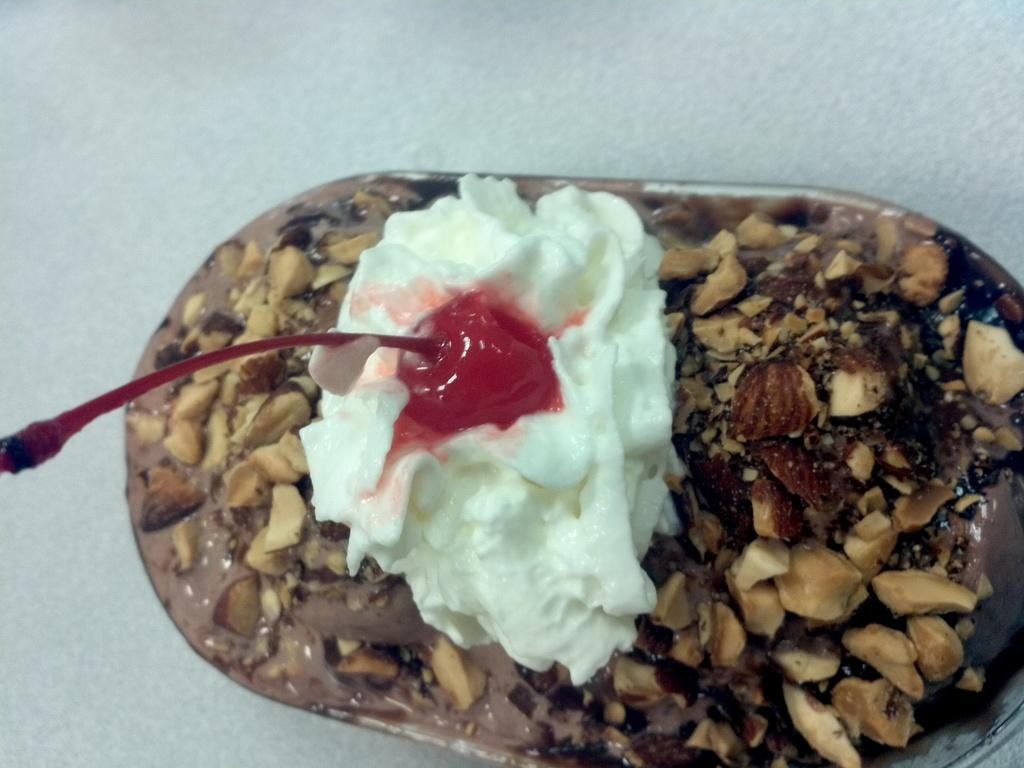What is the main subject of the image? There is a food item in the image. Can you describe the surface on which the food item is placed? The food item is on a white surface. How many basketballs are visible in the image? There are no basketballs present in the image. What type of tree can be seen growing on the white surface? There is no tree present in the image; it features a food item on a white surface. 